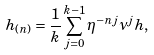<formula> <loc_0><loc_0><loc_500><loc_500>h _ { ( n ) } = \frac { 1 } { k } \sum _ { j = 0 } ^ { k - 1 } \eta ^ { - n j } \nu ^ { j } h ,</formula> 